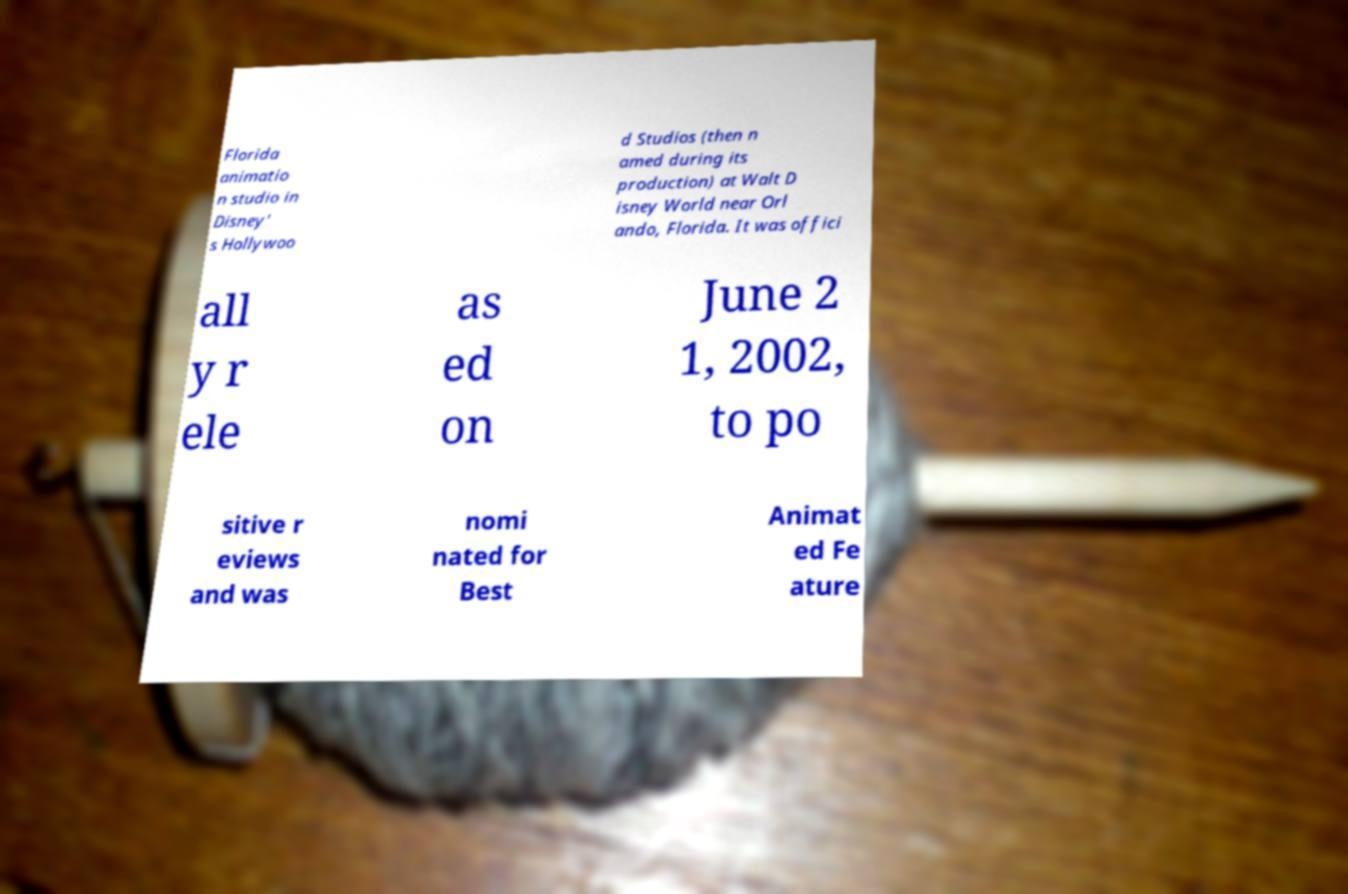Could you assist in decoding the text presented in this image and type it out clearly? Florida animatio n studio in Disney' s Hollywoo d Studios (then n amed during its production) at Walt D isney World near Orl ando, Florida. It was offici all y r ele as ed on June 2 1, 2002, to po sitive r eviews and was nomi nated for Best Animat ed Fe ature 